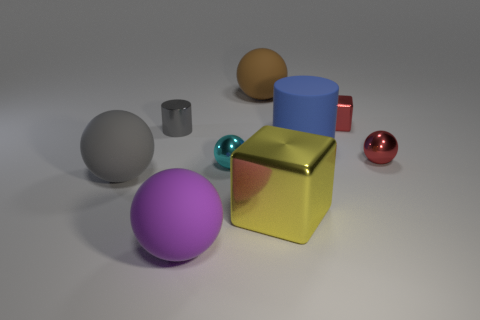What could be the function of the smallest cyan-colored object? Considering its size and isolated position in the composition, the smallest cyan object could be imagined as a decorative piece, perhaps a stand-alone work of miniature art or a part of a game set. 